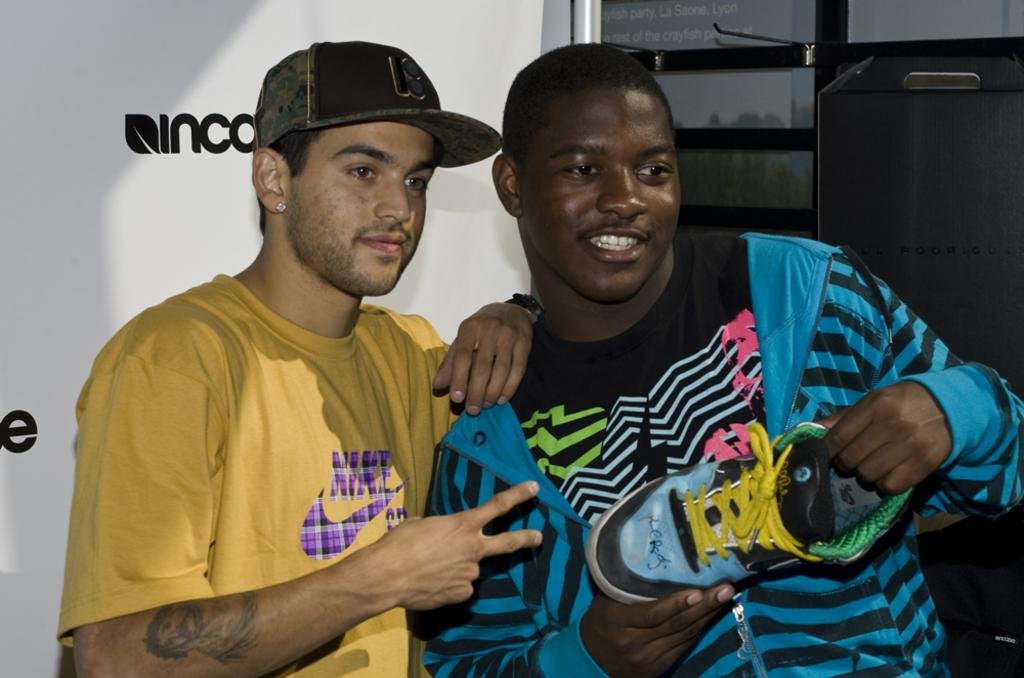<image>
Relay a brief, clear account of the picture shown. A man wearing a yellow Nike shirt is posing with a man holding a shoe. 